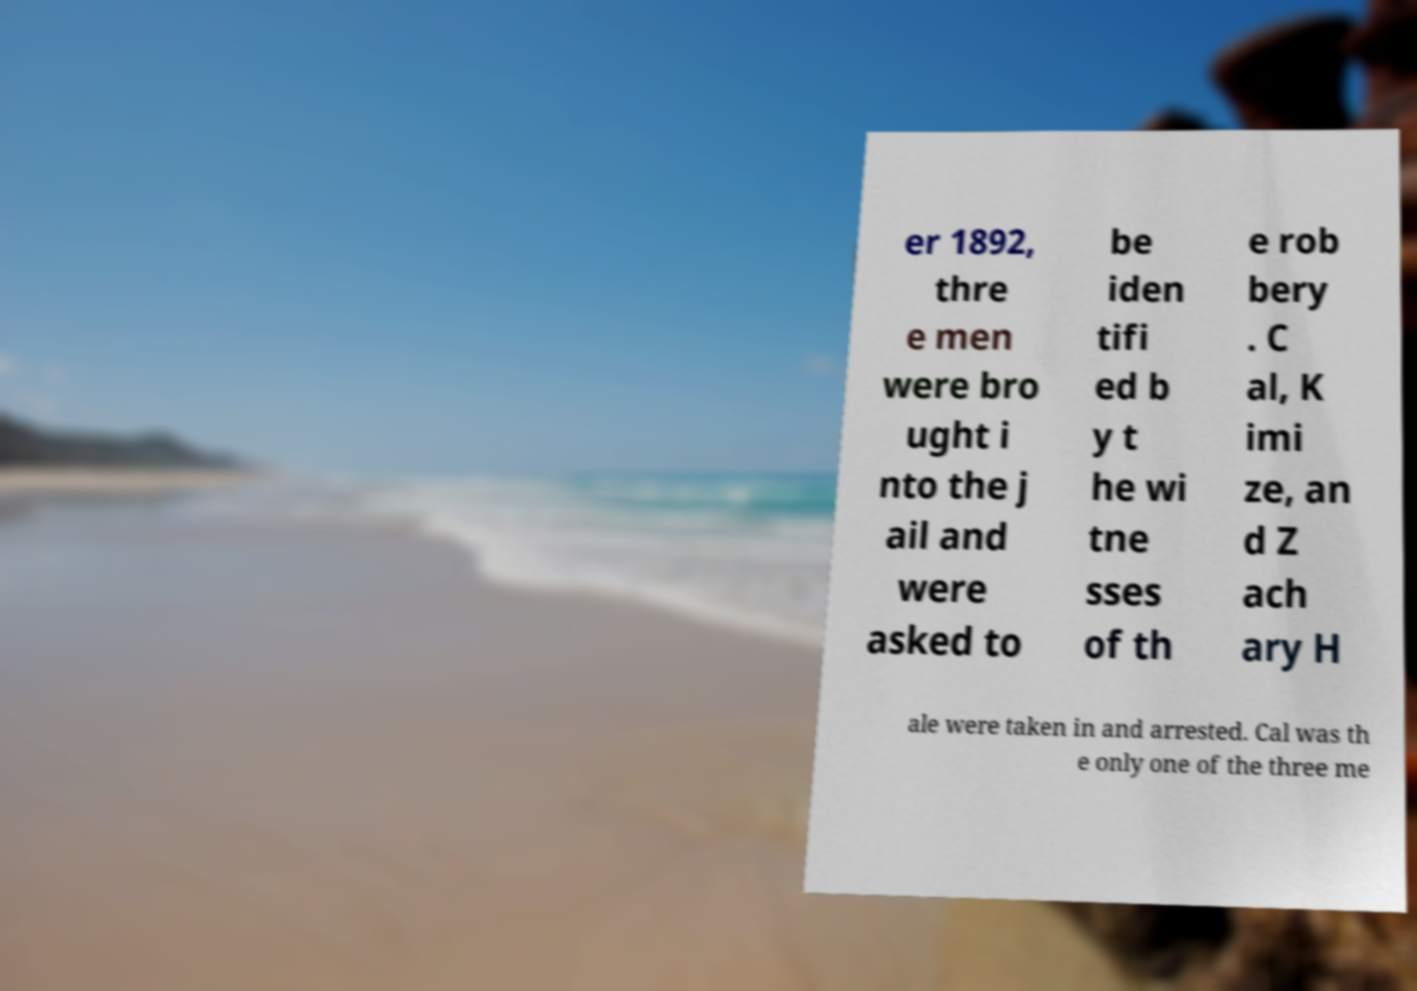Please read and relay the text visible in this image. What does it say? er 1892, thre e men were bro ught i nto the j ail and were asked to be iden tifi ed b y t he wi tne sses of th e rob bery . C al, K imi ze, an d Z ach ary H ale were taken in and arrested. Cal was th e only one of the three me 